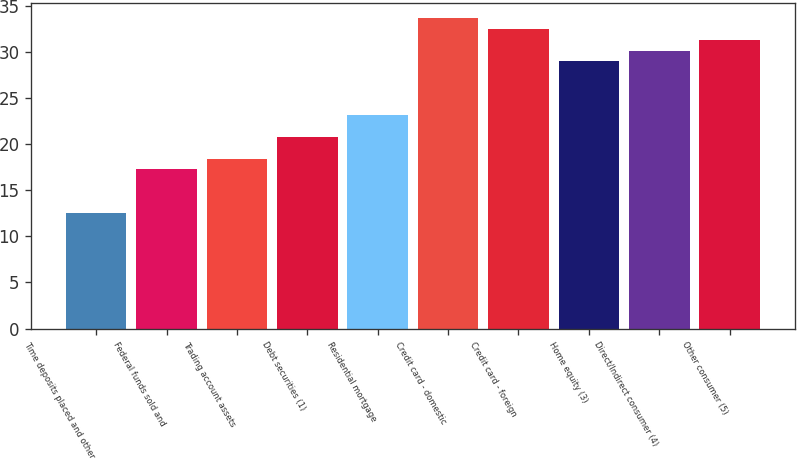Convert chart to OTSL. <chart><loc_0><loc_0><loc_500><loc_500><bar_chart><fcel>Time deposits placed and other<fcel>Federal funds sold and<fcel>Trading account assets<fcel>Debt securities (1)<fcel>Residential mortgage<fcel>Credit card - domestic<fcel>Credit card - foreign<fcel>Home equity (3)<fcel>Direct/Indirect consumer (4)<fcel>Other consumer (5)<nl><fcel>12.57<fcel>17.25<fcel>18.42<fcel>20.76<fcel>23.1<fcel>33.63<fcel>32.46<fcel>28.95<fcel>30.12<fcel>31.29<nl></chart> 